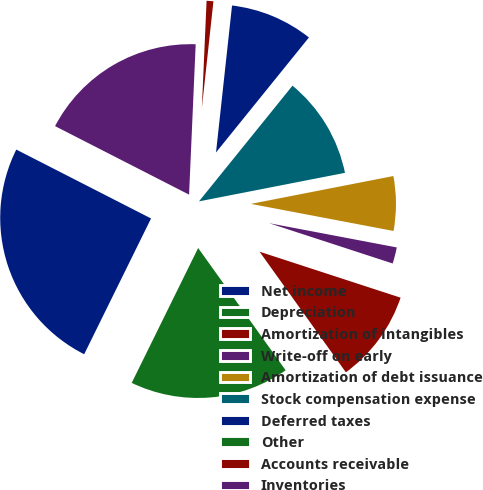<chart> <loc_0><loc_0><loc_500><loc_500><pie_chart><fcel>Net income<fcel>Depreciation<fcel>Amortization of intangibles<fcel>Write-off on early<fcel>Amortization of debt issuance<fcel>Stock compensation expense<fcel>Deferred taxes<fcel>Other<fcel>Accounts receivable<fcel>Inventories<nl><fcel>25.24%<fcel>17.17%<fcel>10.1%<fcel>2.03%<fcel>6.06%<fcel>11.11%<fcel>9.09%<fcel>0.01%<fcel>1.02%<fcel>18.18%<nl></chart> 